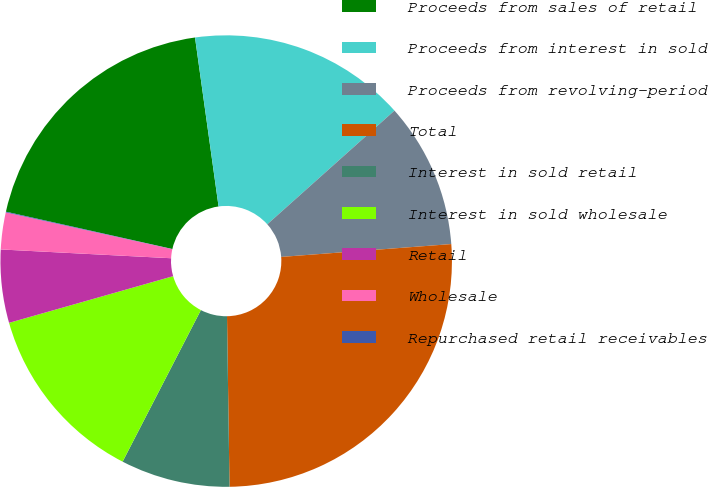Convert chart to OTSL. <chart><loc_0><loc_0><loc_500><loc_500><pie_chart><fcel>Proceeds from sales of retail<fcel>Proceeds from interest in sold<fcel>Proceeds from revolving-period<fcel>Total<fcel>Interest in sold retail<fcel>Interest in sold wholesale<fcel>Retail<fcel>Wholesale<fcel>Repurchased retail receivables<nl><fcel>19.28%<fcel>15.59%<fcel>10.41%<fcel>25.96%<fcel>7.82%<fcel>13.0%<fcel>5.23%<fcel>2.64%<fcel>0.05%<nl></chart> 